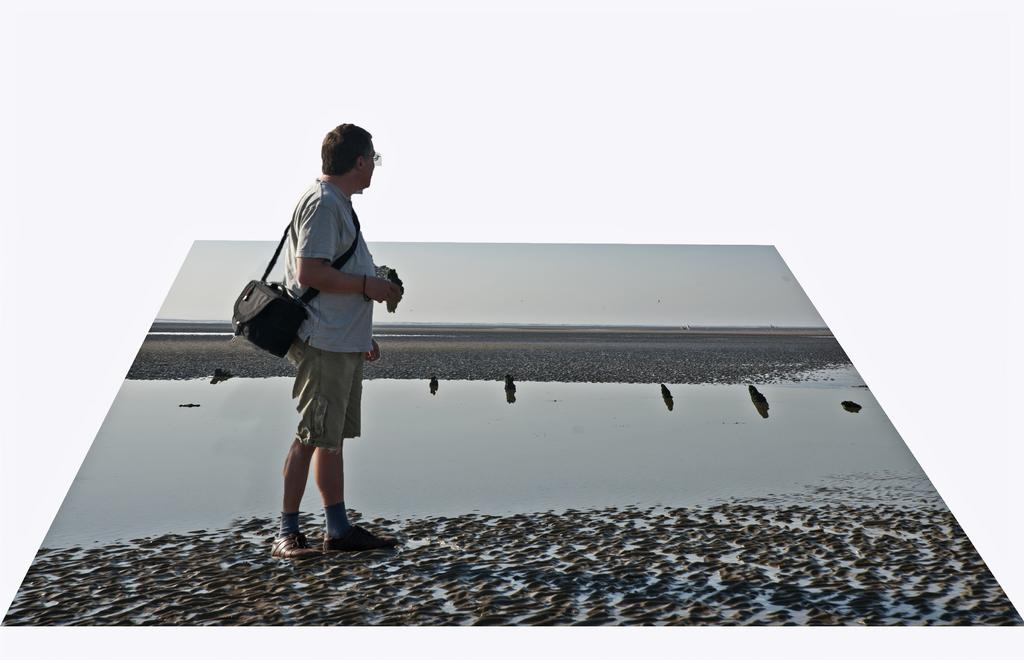Who is present in the image? There is a man in the image. What is the man wearing? The man is wearing a bag. Where is the man standing? The man is standing on mud land. What can be seen in the background of the image? There is a water surface in the image. How many feathers can be seen on the mice in the image? There are no mice or feathers present in the image. What type of patch is visible on the man's clothing in the image? There is no patch visible on the man's clothing in the image. 